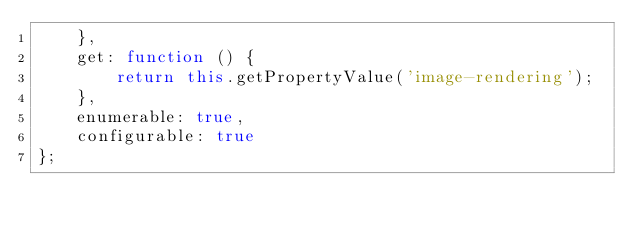Convert code to text. <code><loc_0><loc_0><loc_500><loc_500><_JavaScript_>    },
    get: function () {
        return this.getPropertyValue('image-rendering');
    },
    enumerable: true,
    configurable: true
};
</code> 